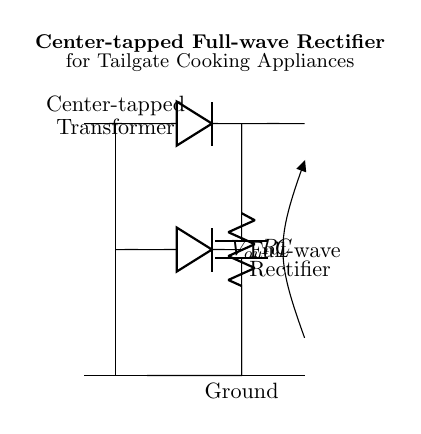what type of rectifier is shown in the diagram? The circuit is identified as a full-wave rectifier because it utilizes both halves of the AC input signal, providing a smoother DC output. The presence of two diodes that conduct during different halves of the AC cycle confirms this.
Answer: full-wave rectifier what is the purpose of the transformer in this circuit? The transformer steps down or steps up the voltage from the AC source to a level suitable for the load. In this case, it ensures the output voltage from the rectifier is within the usable range for cooking appliances at tailgates.
Answer: voltage adjustment how many diodes are present in this circuit? There are two diodes shown in the circuit diagram. Each diode allows current to flow in one direction, enabling the full-wave rectification of the AC input.
Answer: two what is the role of the capacitor in the circuit? The capacitor smooths the output voltage by charging during the peaks of the rectified voltage and discharging during the troughs. This action reduces voltage fluctuations and provides a more stable DC output for the cooking appliances.
Answer: smoothing how is the load resistor connected in the circuit? The load resistor is connected in parallel with the capacitor and diodes, receiving the output rectified voltage. This arrangement allows the appliance to draw power while providing a stabilized voltage.
Answer: in parallel what does the center-tapped configuration indicate about the transformer? The center-tapped configuration means the transformer has a tap in the middle, allowing it to provide two equal voltages from the outer taps to the center tap. This enables the use of both halves of the AC waveform for rectification.
Answer: two equal voltages 